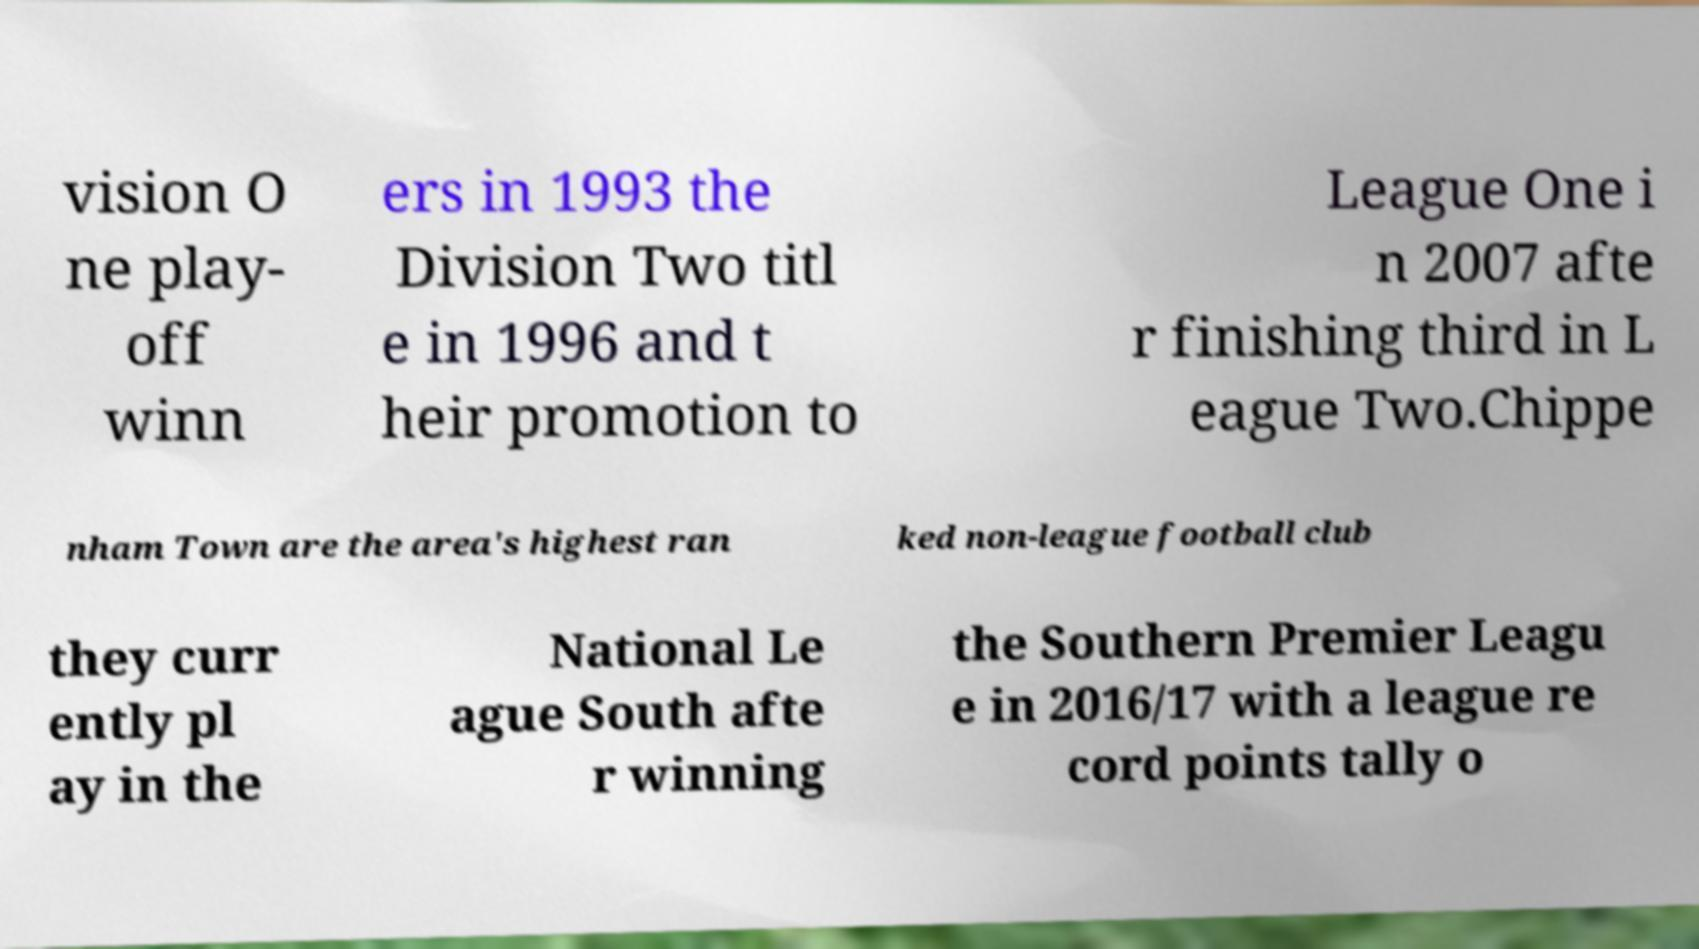Could you extract and type out the text from this image? vision O ne play- off winn ers in 1993 the Division Two titl e in 1996 and t heir promotion to League One i n 2007 afte r finishing third in L eague Two.Chippe nham Town are the area's highest ran ked non-league football club they curr ently pl ay in the National Le ague South afte r winning the Southern Premier Leagu e in 2016/17 with a league re cord points tally o 